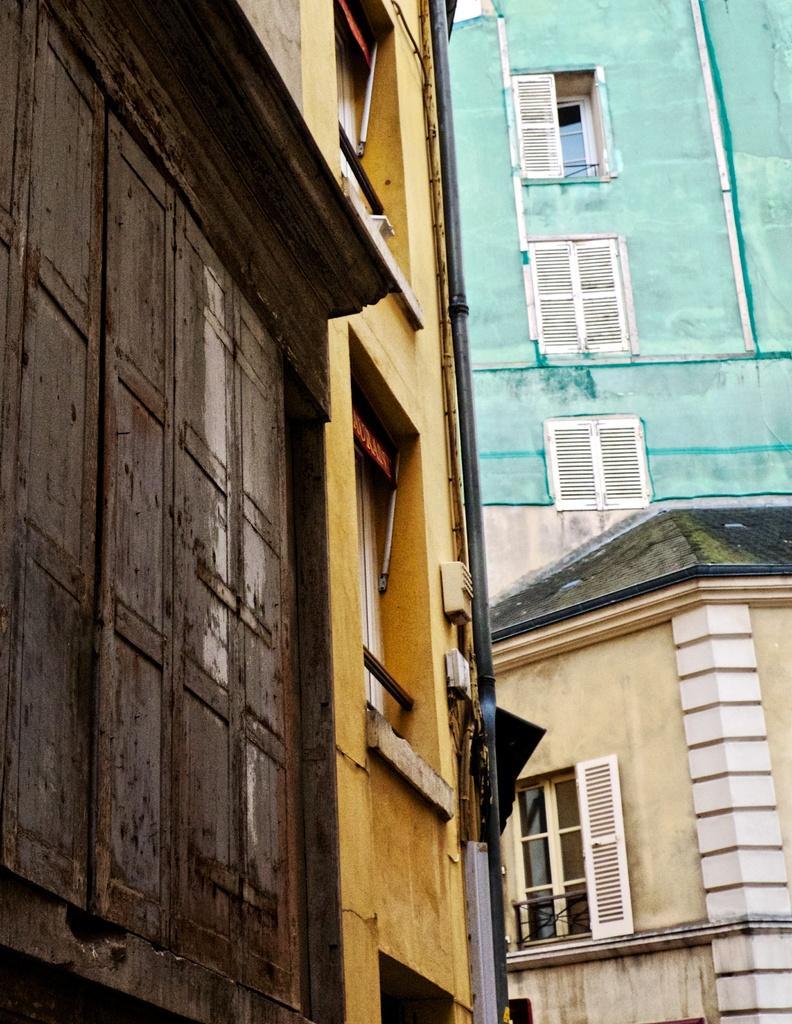Describe this image in one or two sentences. In the image we can see building, the windows of the building and pipe. 